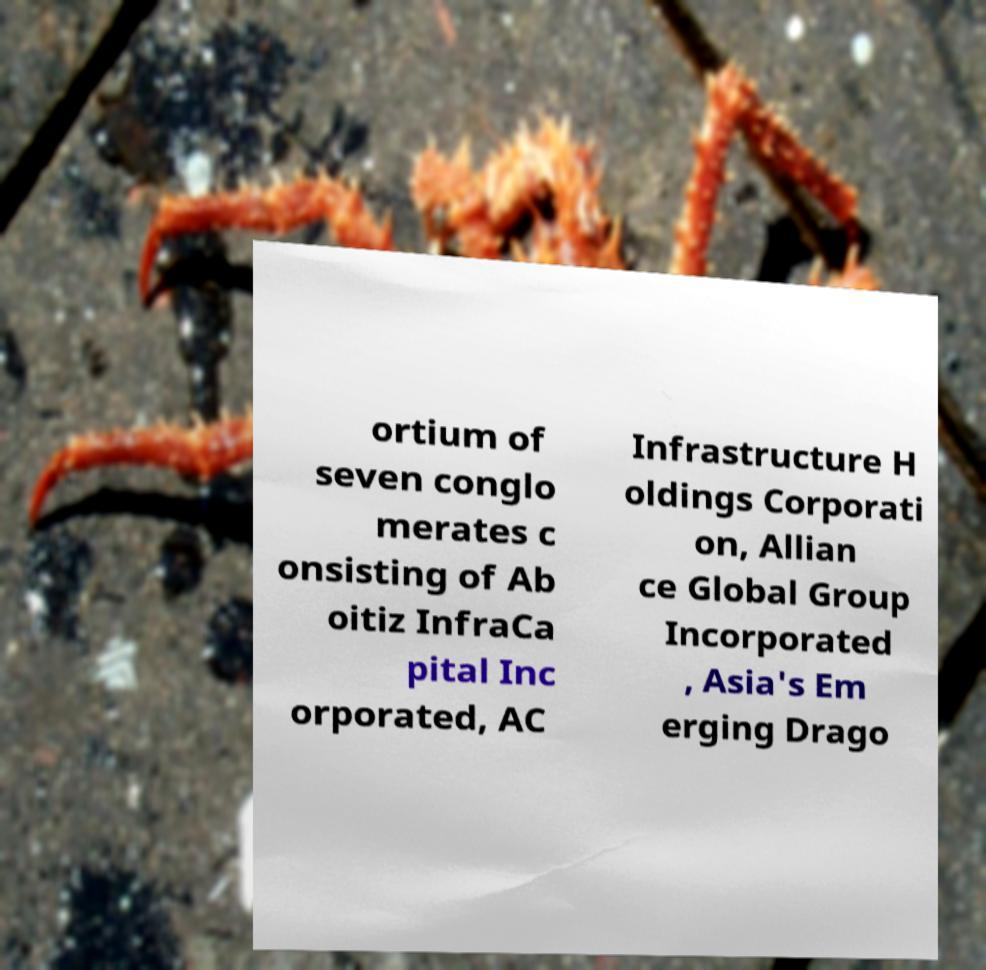For documentation purposes, I need the text within this image transcribed. Could you provide that? ortium of seven conglo merates c onsisting of Ab oitiz InfraCa pital Inc orporated, AC Infrastructure H oldings Corporati on, Allian ce Global Group Incorporated , Asia's Em erging Drago 